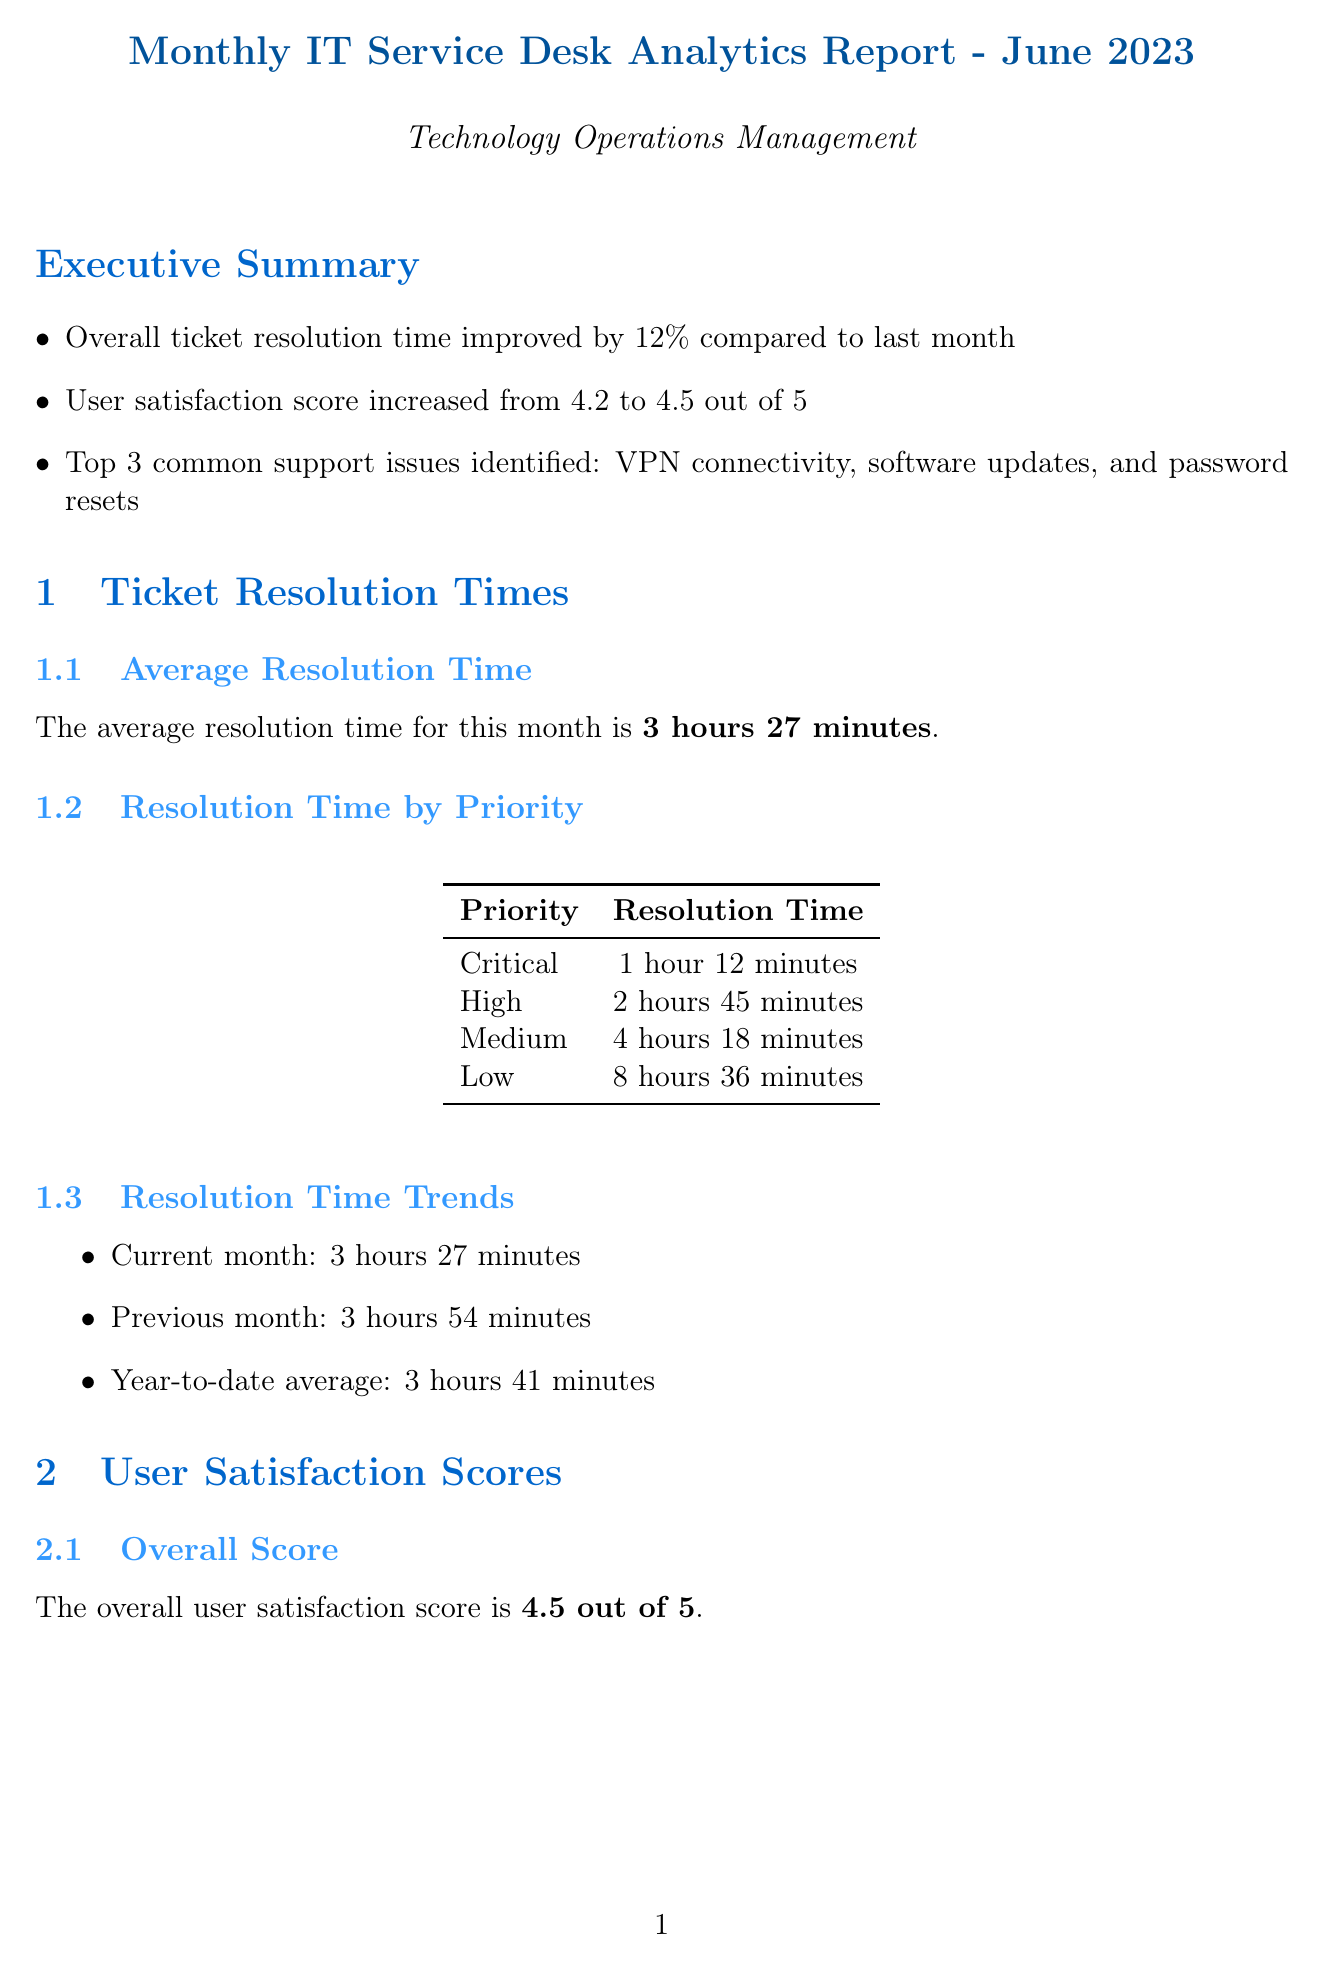what is the average resolution time for June 2023? The average resolution time for June 2023 is highlighted in the document under ticket resolution times.
Answer: 3 hours 27 minutes what was the user satisfaction score last month? The previous month's user satisfaction score is mentioned in the executive summary as a comparison to the current score.
Answer: 4.2 which system had the highest percentage of issues reported? The system with the most issues is noted in the technology impact analysis section, indicating the percentage of issues it represents.
Answer: Cisco AnyConnect VPN what percentage of tickets were resolved on first contact? The service desk performance metrics section specifies the percentage of tickets resolved on first contact.
Answer: 68% what were the average response times for support inquiries? The average response time for support inquiries is outlined in the performance metrics section of the report.
Answer: 12 minutes which emerging issues are noted in the report? The emerging issues are identified in a specific subsection related to common support issues, detailing new areas of concern.
Answer: Increased reports of Microsoft Teams call quality issues what is the overall user satisfaction score? The overall user satisfaction score is presented in the user satisfaction scores section, summarizing the current score out of five.
Answer: 4.5 what are the busiest hours for the service desk? The busiest hours for the service desk staff are detailed under resource utilization in the document.
Answer: 9:00 AM - 11:00 AM, 2:00 PM - 4:00 PM which action items were recommended for addressing VPN issues? The action items addressing VPN issues are found in the conclusion and recommendations section of the report.
Answer: Schedule meeting with network team to address VPN connectivity issues 